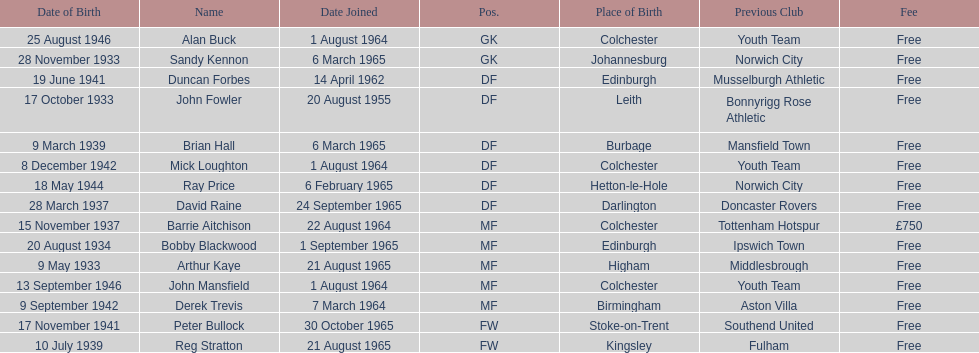Is arthur kaye older or younger than brian hill? Older. 